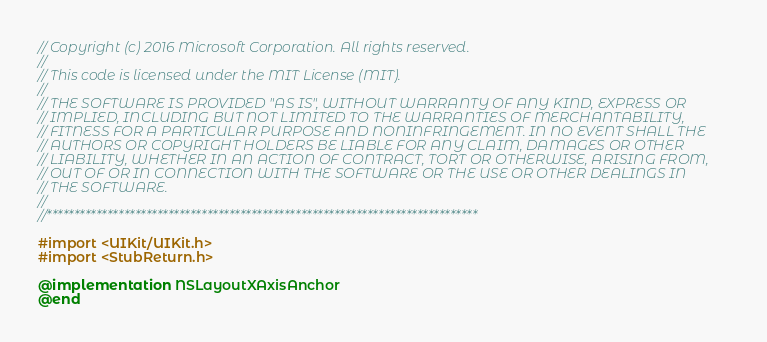<code> <loc_0><loc_0><loc_500><loc_500><_ObjectiveC_>// Copyright (c) 2016 Microsoft Corporation. All rights reserved.
//
// This code is licensed under the MIT License (MIT).
//
// THE SOFTWARE IS PROVIDED "AS IS", WITHOUT WARRANTY OF ANY KIND, EXPRESS OR
// IMPLIED, INCLUDING BUT NOT LIMITED TO THE WARRANTIES OF MERCHANTABILITY,
// FITNESS FOR A PARTICULAR PURPOSE AND NONINFRINGEMENT. IN NO EVENT SHALL THE
// AUTHORS OR COPYRIGHT HOLDERS BE LIABLE FOR ANY CLAIM, DAMAGES OR OTHER
// LIABILITY, WHETHER IN AN ACTION OF CONTRACT, TORT OR OTHERWISE, ARISING FROM,
// OUT OF OR IN CONNECTION WITH THE SOFTWARE OR THE USE OR OTHER DEALINGS IN
// THE SOFTWARE.
//
//******************************************************************************

#import <UIKit/UIKit.h>
#import <StubReturn.h>

@implementation NSLayoutXAxisAnchor
@end
</code> 